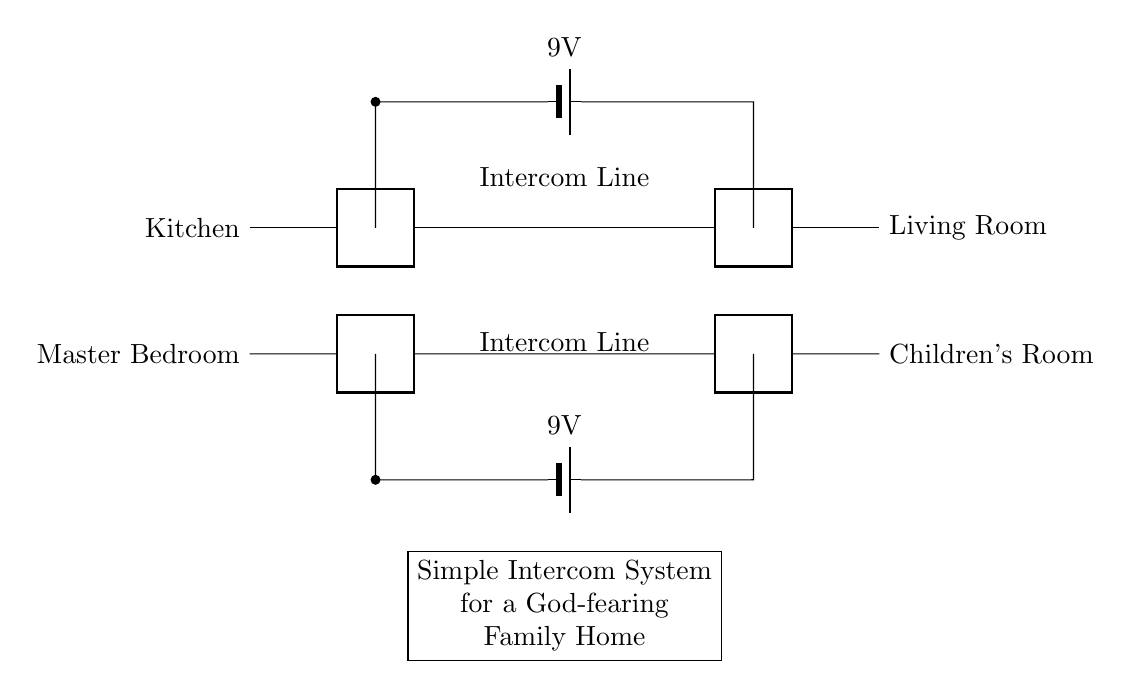What are the two rooms connected on the top line? The top line connects the Kitchen and the Living Room as labeled in the circuit diagram.
Answer: Kitchen and Living Room What voltage is used for the intercom system? The intercom system uses a 9-volt battery as indicated in the circuit diagram next to the battery symbols.
Answer: 9 volts How many intercom lines are shown in the circuit? There are two intercom lines depicted, one between the Kitchen and Living Room and one between the Master Bedroom and Children's Room.
Answer: Two What type of battery is used in this circuit? The circuit features a 9-volt battery, which is specified next to the battery graphic in the diagram.
Answer: 9-volt battery Which rooms are connected on the bottom line? The bottom line connects the Master Bedroom and the Children's Room according to the labels in the circuit diagram.
Answer: Master Bedroom and Children's Room Why are there two batteries in the circuit? Each battery powers a separate intercom line, providing independent power sources for communication between the different pairs of rooms: one for the top line and another for the bottom line.
Answer: To power two intercom lines What is the purpose of the twoport component in this diagram? The twoport component represents the intercom connections, facilitating communication between the rooms connected by the intercom lines.
Answer: Communication 